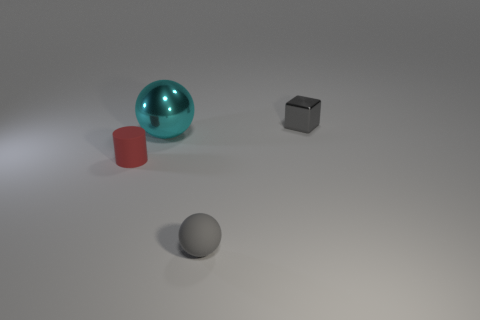Add 1 gray objects. How many objects exist? 5 Subtract all cubes. How many objects are left? 3 Subtract all big cyan metallic spheres. Subtract all matte cylinders. How many objects are left? 2 Add 1 big cyan metal objects. How many big cyan metal objects are left? 2 Add 2 small matte cylinders. How many small matte cylinders exist? 3 Subtract 1 red cylinders. How many objects are left? 3 